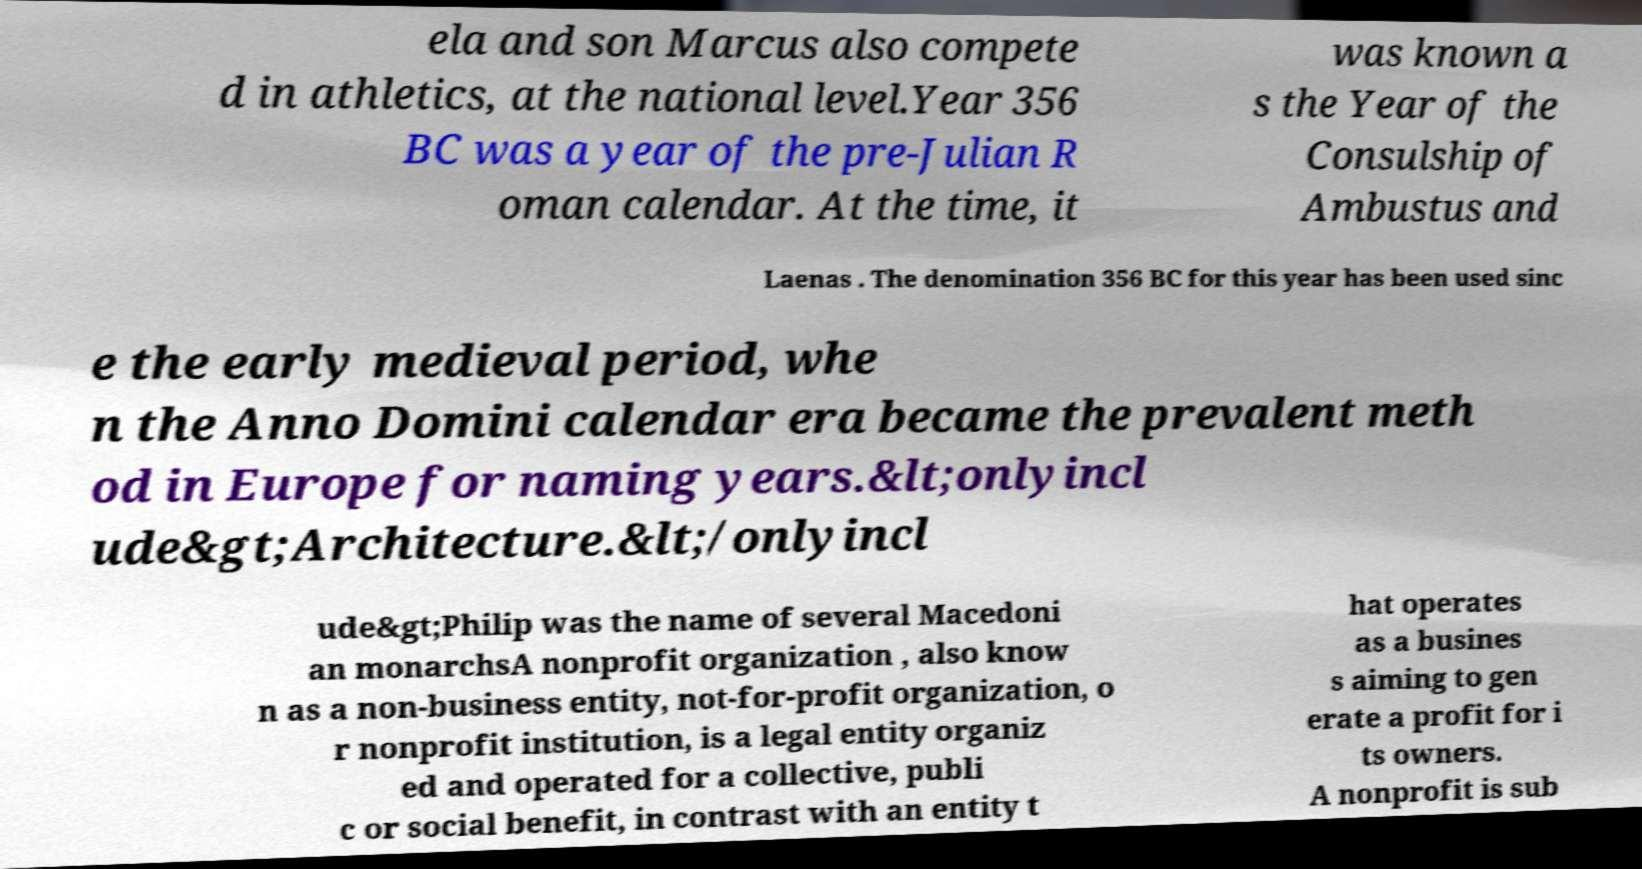Please identify and transcribe the text found in this image. ela and son Marcus also compete d in athletics, at the national level.Year 356 BC was a year of the pre-Julian R oman calendar. At the time, it was known a s the Year of the Consulship of Ambustus and Laenas . The denomination 356 BC for this year has been used sinc e the early medieval period, whe n the Anno Domini calendar era became the prevalent meth od in Europe for naming years.&lt;onlyincl ude&gt;Architecture.&lt;/onlyincl ude&gt;Philip was the name of several Macedoni an monarchsA nonprofit organization , also know n as a non-business entity, not-for-profit organization, o r nonprofit institution, is a legal entity organiz ed and operated for a collective, publi c or social benefit, in contrast with an entity t hat operates as a busines s aiming to gen erate a profit for i ts owners. A nonprofit is sub 